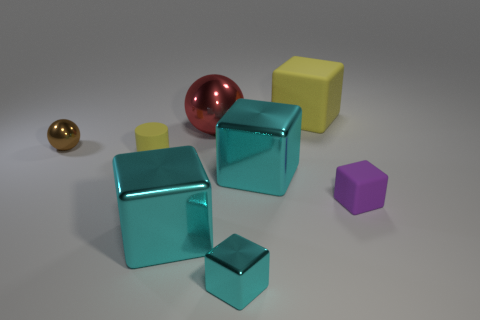How many cyan cubes must be subtracted to get 1 cyan cubes? 2 Subtract all large shiny cubes. How many cubes are left? 3 Subtract 0 brown cubes. How many objects are left? 8 Subtract all balls. How many objects are left? 6 Subtract 1 cylinders. How many cylinders are left? 0 Subtract all green spheres. Subtract all purple cylinders. How many spheres are left? 2 Subtract all purple cylinders. How many brown spheres are left? 1 Subtract all big yellow rubber cubes. Subtract all large red metallic things. How many objects are left? 6 Add 5 small yellow objects. How many small yellow objects are left? 6 Add 6 small metal things. How many small metal things exist? 8 